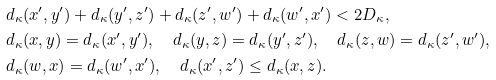<formula> <loc_0><loc_0><loc_500><loc_500>& d _ { \kappa } ( x ^ { \prime } , y ^ { \prime } ) + d _ { \kappa } ( y ^ { \prime } , z ^ { \prime } ) + d _ { \kappa } ( z ^ { \prime } , w ^ { \prime } ) + d _ { \kappa } ( w ^ { \prime } , x ^ { \prime } ) < 2 D _ { \kappa } , \\ & d _ { \kappa } ( x , y ) = d _ { \kappa } ( x ^ { \prime } , y ^ { \prime } ) , \quad d _ { \kappa } ( y , z ) = d _ { \kappa } ( y ^ { \prime } , z ^ { \prime } ) , \quad d _ { \kappa } ( z , w ) = d _ { \kappa } ( z ^ { \prime } , w ^ { \prime } ) , \\ & d _ { \kappa } ( w , x ) = d _ { \kappa } ( w ^ { \prime } , x ^ { \prime } ) , \quad d _ { \kappa } ( x ^ { \prime } , z ^ { \prime } ) \leq d _ { \kappa } ( x , z ) .</formula> 